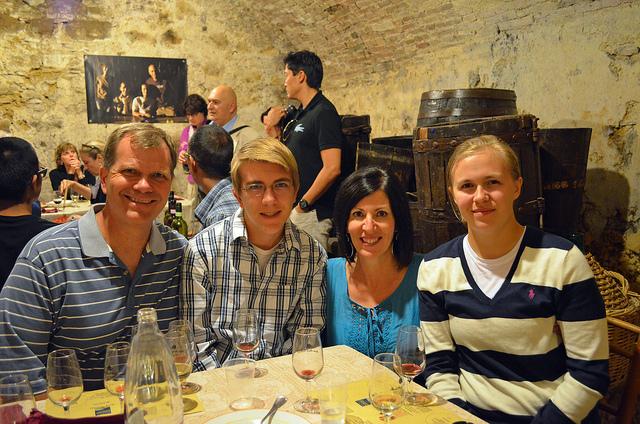What are the men doing?
Write a very short answer. Smiling. Have they already had drinks?
Write a very short answer. Yes. Are they at a restaurant?
Short answer required. Yes. What color is the women's top?
Answer briefly. Blue. Is it a happy occasion?
Keep it brief. Yes. 